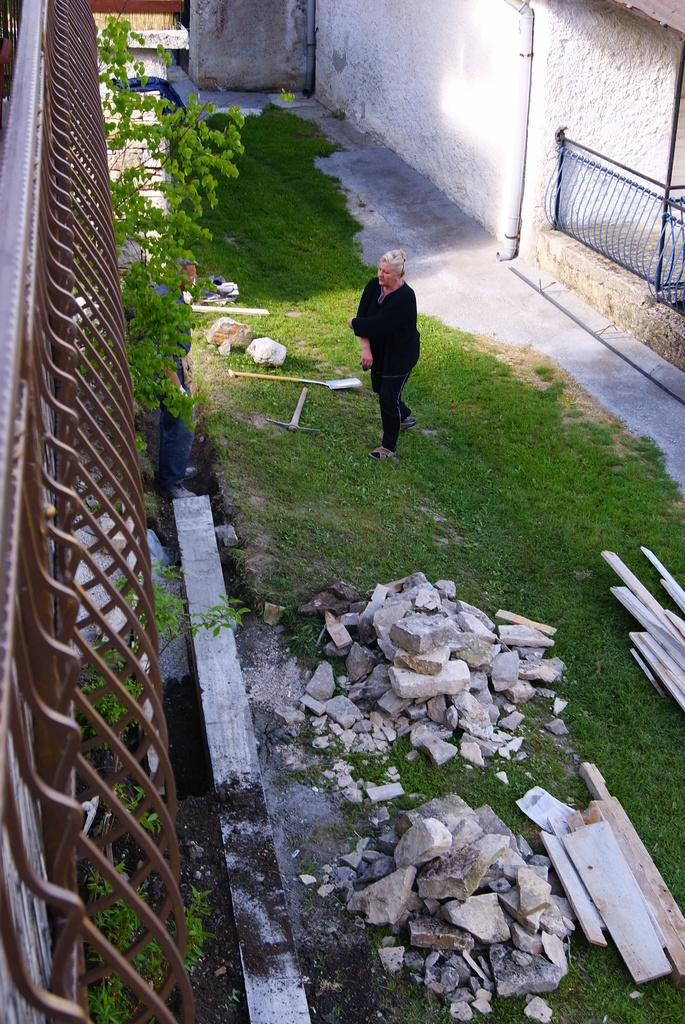What is the woman doing in the image? The woman is standing on the ground in the image. What type of infrastructure can be seen in the image? Pipelines and iron grills are visible in the image. What is the man doing in the image? The man is standing on a wall in the image. What type of natural elements are present in the image? Trees and stones are visible in the image. What type of construction materials are present in the image? Wooden bars are present in the image. What type of tools are visible in the image? Gardening tools are visible in the image. What language is the woman speaking to the grandmother in the image? There is no grandmother or language spoken in the image. 